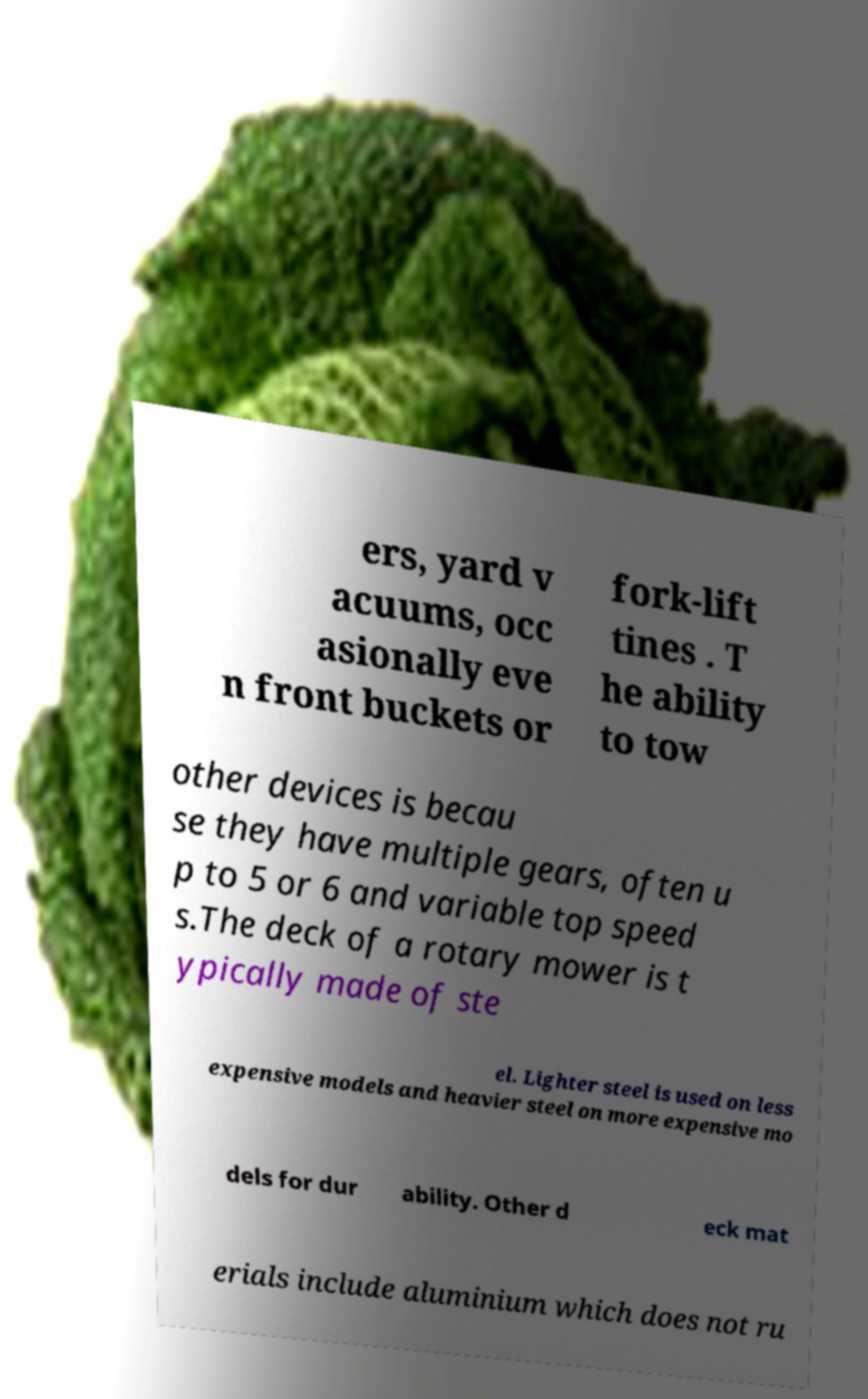Can you read and provide the text displayed in the image?This photo seems to have some interesting text. Can you extract and type it out for me? ers, yard v acuums, occ asionally eve n front buckets or fork-lift tines . T he ability to tow other devices is becau se they have multiple gears, often u p to 5 or 6 and variable top speed s.The deck of a rotary mower is t ypically made of ste el. Lighter steel is used on less expensive models and heavier steel on more expensive mo dels for dur ability. Other d eck mat erials include aluminium which does not ru 